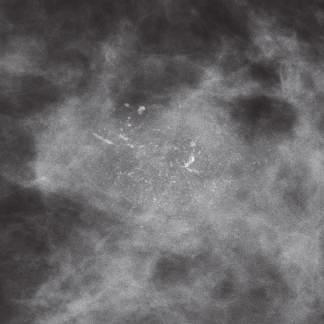s mammographic detection of calcifications associated with dcis?
Answer the question using a single word or phrase. Yes 